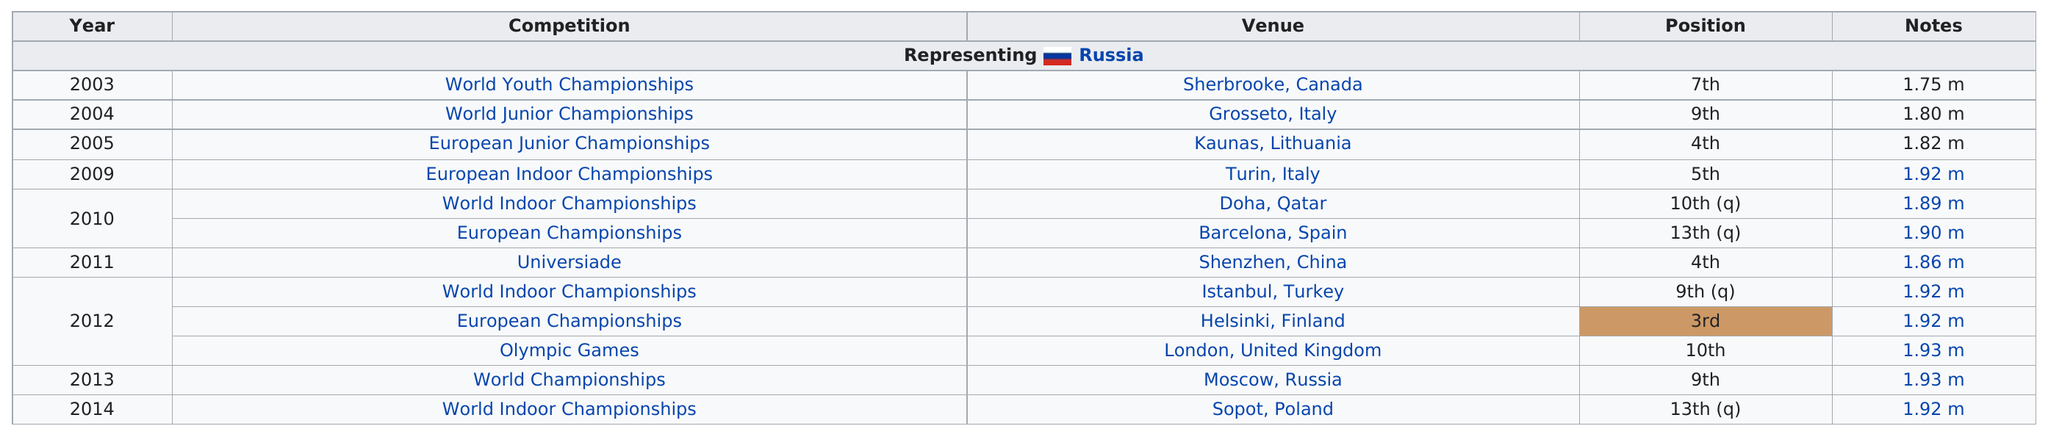Outline some significant characteristics in this image. The World Youth Championships is known for having the least amount of notes out of all competitions. The next competition after the 2009 World Championships was the World Indoor Championships. There are 12 venues. Gordeeva has achieved a top 3 finish on 1 occasion. Irina jumped above 1.9 meters at six competitions. 